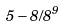Convert formula to latex. <formula><loc_0><loc_0><loc_500><loc_500>5 - 8 / 8 ^ { 9 }</formula> 